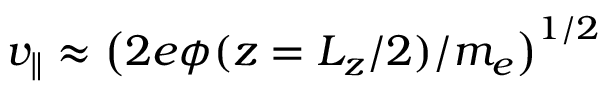<formula> <loc_0><loc_0><loc_500><loc_500>v _ { \| } \approx \left ( 2 e \phi ( z = L _ { z } / 2 ) / m _ { e } \right ) ^ { 1 / 2 }</formula> 